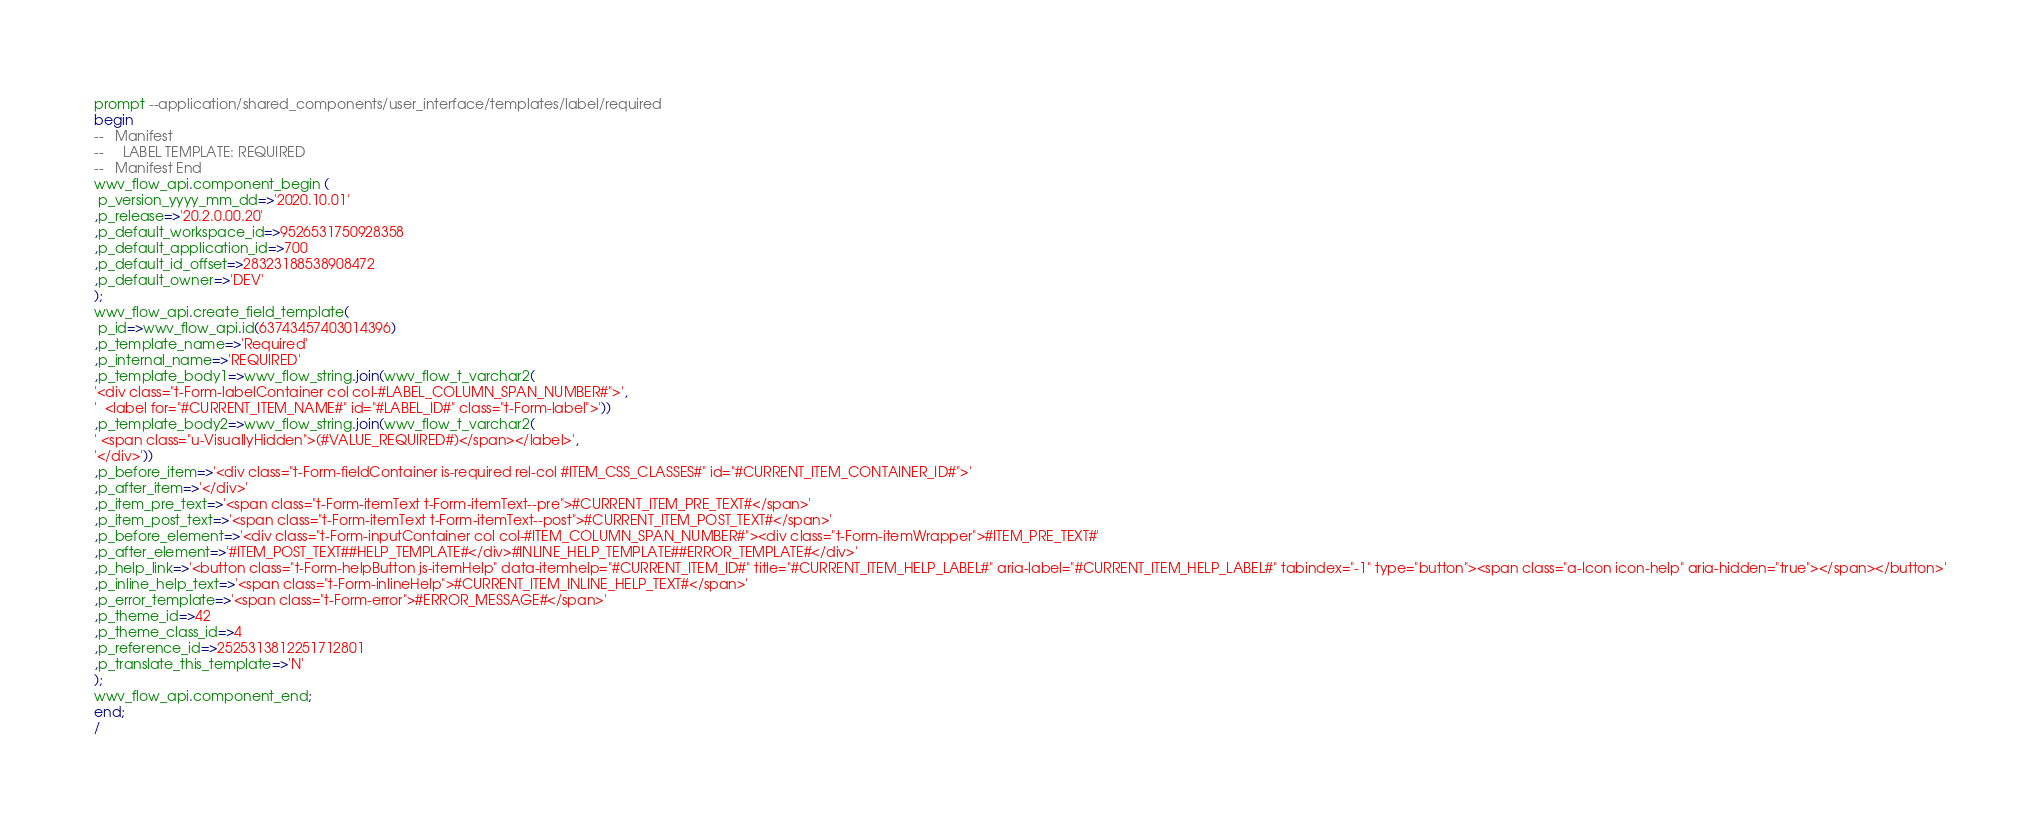Convert code to text. <code><loc_0><loc_0><loc_500><loc_500><_SQL_>prompt --application/shared_components/user_interface/templates/label/required
begin
--   Manifest
--     LABEL TEMPLATE: REQUIRED
--   Manifest End
wwv_flow_api.component_begin (
 p_version_yyyy_mm_dd=>'2020.10.01'
,p_release=>'20.2.0.00.20'
,p_default_workspace_id=>9526531750928358
,p_default_application_id=>700
,p_default_id_offset=>28323188538908472
,p_default_owner=>'DEV'
);
wwv_flow_api.create_field_template(
 p_id=>wwv_flow_api.id(63743457403014396)
,p_template_name=>'Required'
,p_internal_name=>'REQUIRED'
,p_template_body1=>wwv_flow_string.join(wwv_flow_t_varchar2(
'<div class="t-Form-labelContainer col col-#LABEL_COLUMN_SPAN_NUMBER#">',
'  <label for="#CURRENT_ITEM_NAME#" id="#LABEL_ID#" class="t-Form-label">'))
,p_template_body2=>wwv_flow_string.join(wwv_flow_t_varchar2(
' <span class="u-VisuallyHidden">(#VALUE_REQUIRED#)</span></label>',
'</div>'))
,p_before_item=>'<div class="t-Form-fieldContainer is-required rel-col #ITEM_CSS_CLASSES#" id="#CURRENT_ITEM_CONTAINER_ID#">'
,p_after_item=>'</div>'
,p_item_pre_text=>'<span class="t-Form-itemText t-Form-itemText--pre">#CURRENT_ITEM_PRE_TEXT#</span>'
,p_item_post_text=>'<span class="t-Form-itemText t-Form-itemText--post">#CURRENT_ITEM_POST_TEXT#</span>'
,p_before_element=>'<div class="t-Form-inputContainer col col-#ITEM_COLUMN_SPAN_NUMBER#"><div class="t-Form-itemWrapper">#ITEM_PRE_TEXT#'
,p_after_element=>'#ITEM_POST_TEXT##HELP_TEMPLATE#</div>#INLINE_HELP_TEMPLATE##ERROR_TEMPLATE#</div>'
,p_help_link=>'<button class="t-Form-helpButton js-itemHelp" data-itemhelp="#CURRENT_ITEM_ID#" title="#CURRENT_ITEM_HELP_LABEL#" aria-label="#CURRENT_ITEM_HELP_LABEL#" tabindex="-1" type="button"><span class="a-Icon icon-help" aria-hidden="true"></span></button>'
,p_inline_help_text=>'<span class="t-Form-inlineHelp">#CURRENT_ITEM_INLINE_HELP_TEXT#</span>'
,p_error_template=>'<span class="t-Form-error">#ERROR_MESSAGE#</span>'
,p_theme_id=>42
,p_theme_class_id=>4
,p_reference_id=>2525313812251712801
,p_translate_this_template=>'N'
);
wwv_flow_api.component_end;
end;
/
</code> 